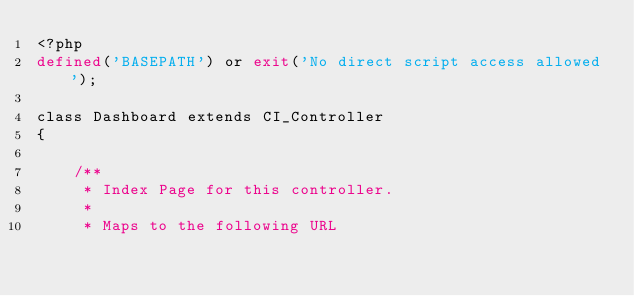Convert code to text. <code><loc_0><loc_0><loc_500><loc_500><_PHP_><?php
defined('BASEPATH') or exit('No direct script access allowed');

class Dashboard extends CI_Controller
{

    /**
     * Index Page for this controller.
     *
     * Maps to the following URL</code> 